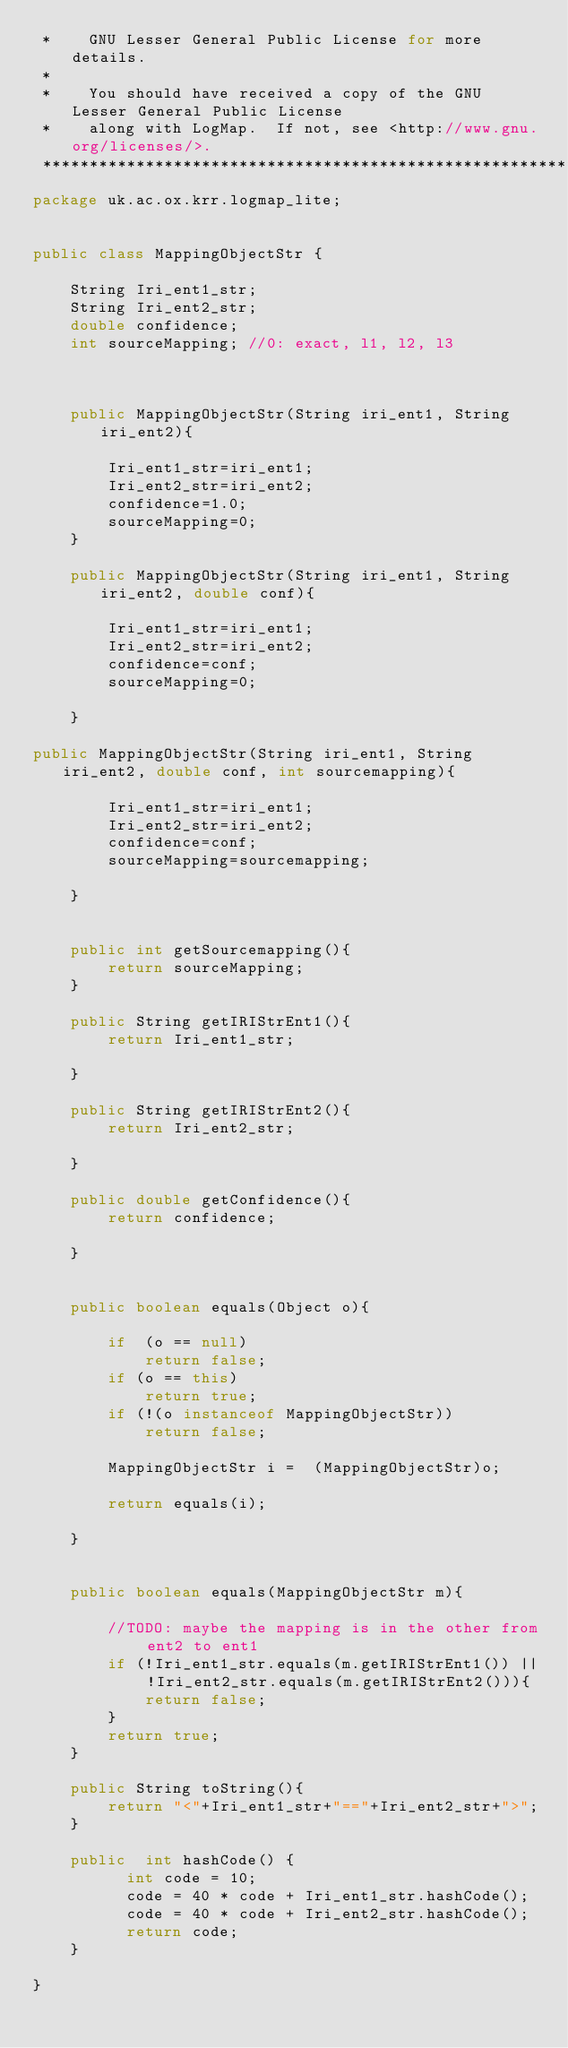<code> <loc_0><loc_0><loc_500><loc_500><_Java_> *    GNU Lesser General Public License for more details.
 * 
 *    You should have received a copy of the GNU Lesser General Public License
 *    along with LogMap.  If not, see <http://www.gnu.org/licenses/>.
 ******************************************************************************/
package uk.ac.ox.krr.logmap_lite;


public class MappingObjectStr {

	String Iri_ent1_str;
	String Iri_ent2_str;
	double confidence;
	int sourceMapping; //0: exact, l1, l2, l3
	
	
	
	public MappingObjectStr(String iri_ent1, String iri_ent2){
		
		Iri_ent1_str=iri_ent1;
		Iri_ent2_str=iri_ent2;
		confidence=1.0;
		sourceMapping=0;
	}
	
	public MappingObjectStr(String iri_ent1, String iri_ent2, double conf){
		
		Iri_ent1_str=iri_ent1;
		Iri_ent2_str=iri_ent2;
		confidence=conf;
		sourceMapping=0;
		
	}
	
public MappingObjectStr(String iri_ent1, String iri_ent2, double conf, int sourcemapping){
		
		Iri_ent1_str=iri_ent1;
		Iri_ent2_str=iri_ent2;
		confidence=conf;
		sourceMapping=sourcemapping;
		
	}
	

	public int getSourcemapping(){
		return sourceMapping;
	}
	
	public String getIRIStrEnt1(){
		return Iri_ent1_str;
		
	}
	
	public String getIRIStrEnt2(){
		return Iri_ent2_str;
		
	}
	
	public double getConfidence(){
		return confidence;
		
	}
	
	
	public boolean equals(Object o){
		
		if  (o == null)
			return false;
		if (o == this)
			return true;
		if (!(o instanceof MappingObjectStr))
			return false;
		
		MappingObjectStr i =  (MappingObjectStr)o;
		
		return equals(i);
		
	}
	
	
	public boolean equals(MappingObjectStr m){
		
		//TODO: maybe the mapping is in the other from ent2 to ent1
		if (!Iri_ent1_str.equals(m.getIRIStrEnt1()) || !Iri_ent2_str.equals(m.getIRIStrEnt2())){
			return false;
		}
		return true;
	}
	
	public String toString(){
		return "<"+Iri_ent1_str+"=="+Iri_ent2_str+">";
	}
	
	public  int hashCode() {
		  int code = 10;
		  code = 40 * code + Iri_ent1_str.hashCode();
		  code = 40 * code + Iri_ent2_str.hashCode();
		  return code;
	}
	
}
</code> 